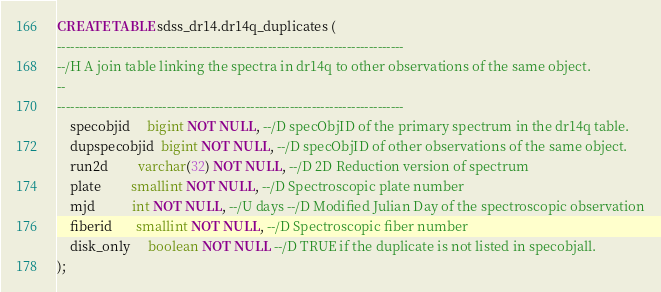<code> <loc_0><loc_0><loc_500><loc_500><_SQL_>CREATE TABLE sdss_dr14.dr14q_duplicates (
-------------------------------------------------------------------------------
--/H A join table linking the spectra in dr14q to other observations of the same object.
--
-------------------------------------------------------------------------------
    specobjid     bigint NOT NULL, --/D specObjID of the primary spectrum in the dr14q table.
    dupspecobjid  bigint NOT NULL, --/D specObjID of other observations of the same object.
    run2d         varchar(32) NOT NULL, --/D 2D Reduction version of spectrum
    plate         smallint NOT NULL, --/D Spectroscopic plate number
    mjd           int NOT NULL, --/U days --/D Modified Julian Day of the spectroscopic observation
    fiberid       smallint NOT NULL, --/D Spectroscopic fiber number
    disk_only     boolean NOT NULL --/D TRUE if the duplicate is not listed in specobjall.
);
</code> 